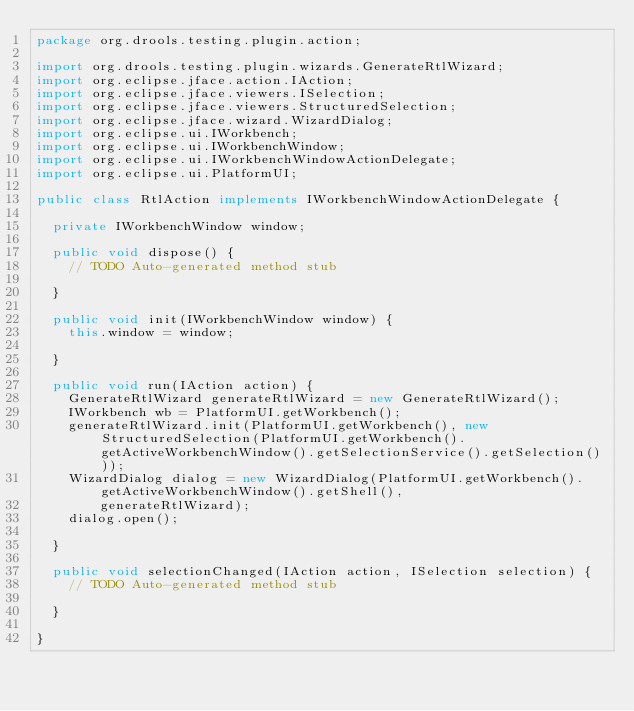Convert code to text. <code><loc_0><loc_0><loc_500><loc_500><_Java_>package org.drools.testing.plugin.action;

import org.drools.testing.plugin.wizards.GenerateRtlWizard;
import org.eclipse.jface.action.IAction;
import org.eclipse.jface.viewers.ISelection;
import org.eclipse.jface.viewers.StructuredSelection;
import org.eclipse.jface.wizard.WizardDialog;
import org.eclipse.ui.IWorkbench;
import org.eclipse.ui.IWorkbenchWindow;
import org.eclipse.ui.IWorkbenchWindowActionDelegate;
import org.eclipse.ui.PlatformUI;

public class RtlAction implements IWorkbenchWindowActionDelegate {
	
	private IWorkbenchWindow window;

	public void dispose() {
		// TODO Auto-generated method stub

	}

	public void init(IWorkbenchWindow window) {
		this.window = window;

	}

	public void run(IAction action) {
		GenerateRtlWizard generateRtlWizard = new GenerateRtlWizard();
		IWorkbench wb = PlatformUI.getWorkbench();
		generateRtlWizard.init(PlatformUI.getWorkbench(), new StructuredSelection(PlatformUI.getWorkbench().getActiveWorkbenchWindow().getSelectionService().getSelection()));
		WizardDialog dialog = new WizardDialog(PlatformUI.getWorkbench().getActiveWorkbenchWindow().getShell(), 
				generateRtlWizard);
		dialog.open();

	}

	public void selectionChanged(IAction action, ISelection selection) {
		// TODO Auto-generated method stub

	}

}
</code> 